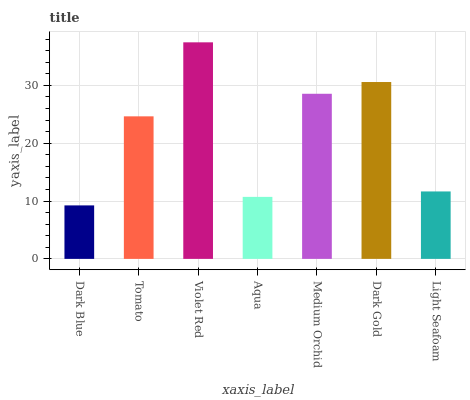Is Dark Blue the minimum?
Answer yes or no. Yes. Is Violet Red the maximum?
Answer yes or no. Yes. Is Tomato the minimum?
Answer yes or no. No. Is Tomato the maximum?
Answer yes or no. No. Is Tomato greater than Dark Blue?
Answer yes or no. Yes. Is Dark Blue less than Tomato?
Answer yes or no. Yes. Is Dark Blue greater than Tomato?
Answer yes or no. No. Is Tomato less than Dark Blue?
Answer yes or no. No. Is Tomato the high median?
Answer yes or no. Yes. Is Tomato the low median?
Answer yes or no. Yes. Is Dark Gold the high median?
Answer yes or no. No. Is Violet Red the low median?
Answer yes or no. No. 